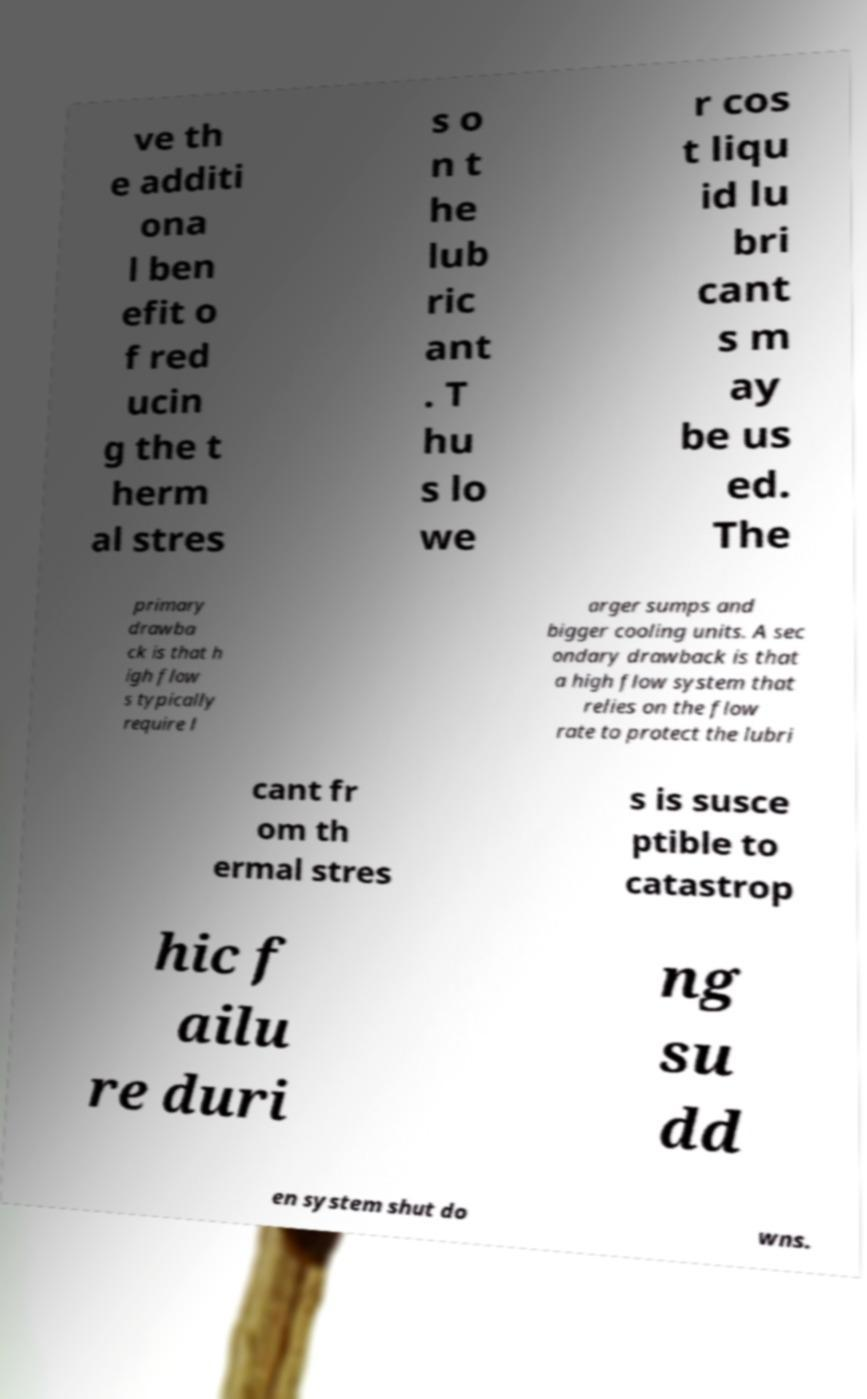Could you assist in decoding the text presented in this image and type it out clearly? ve th e additi ona l ben efit o f red ucin g the t herm al stres s o n t he lub ric ant . T hu s lo we r cos t liqu id lu bri cant s m ay be us ed. The primary drawba ck is that h igh flow s typically require l arger sumps and bigger cooling units. A sec ondary drawback is that a high flow system that relies on the flow rate to protect the lubri cant fr om th ermal stres s is susce ptible to catastrop hic f ailu re duri ng su dd en system shut do wns. 